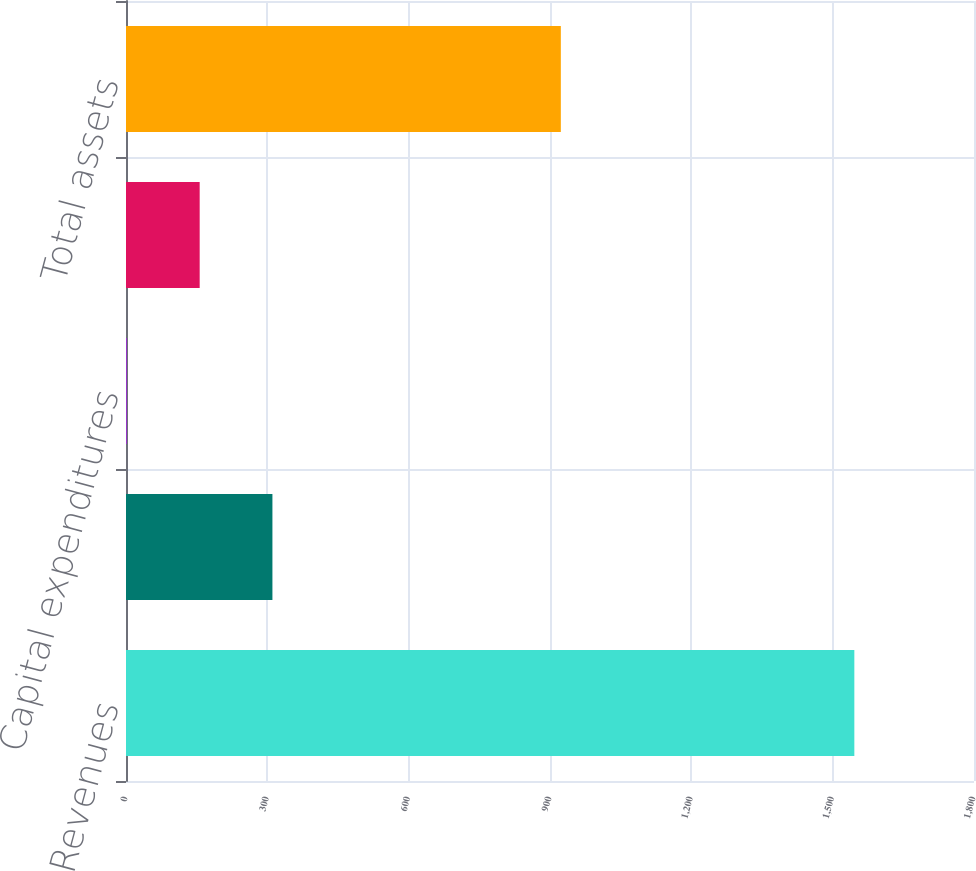Convert chart to OTSL. <chart><loc_0><loc_0><loc_500><loc_500><bar_chart><fcel>Revenues<fcel>Operating profit<fcel>Capital expenditures<fcel>Depreciation and amortization<fcel>Total assets<nl><fcel>1546<fcel>310.8<fcel>2<fcel>156.4<fcel>923<nl></chart> 